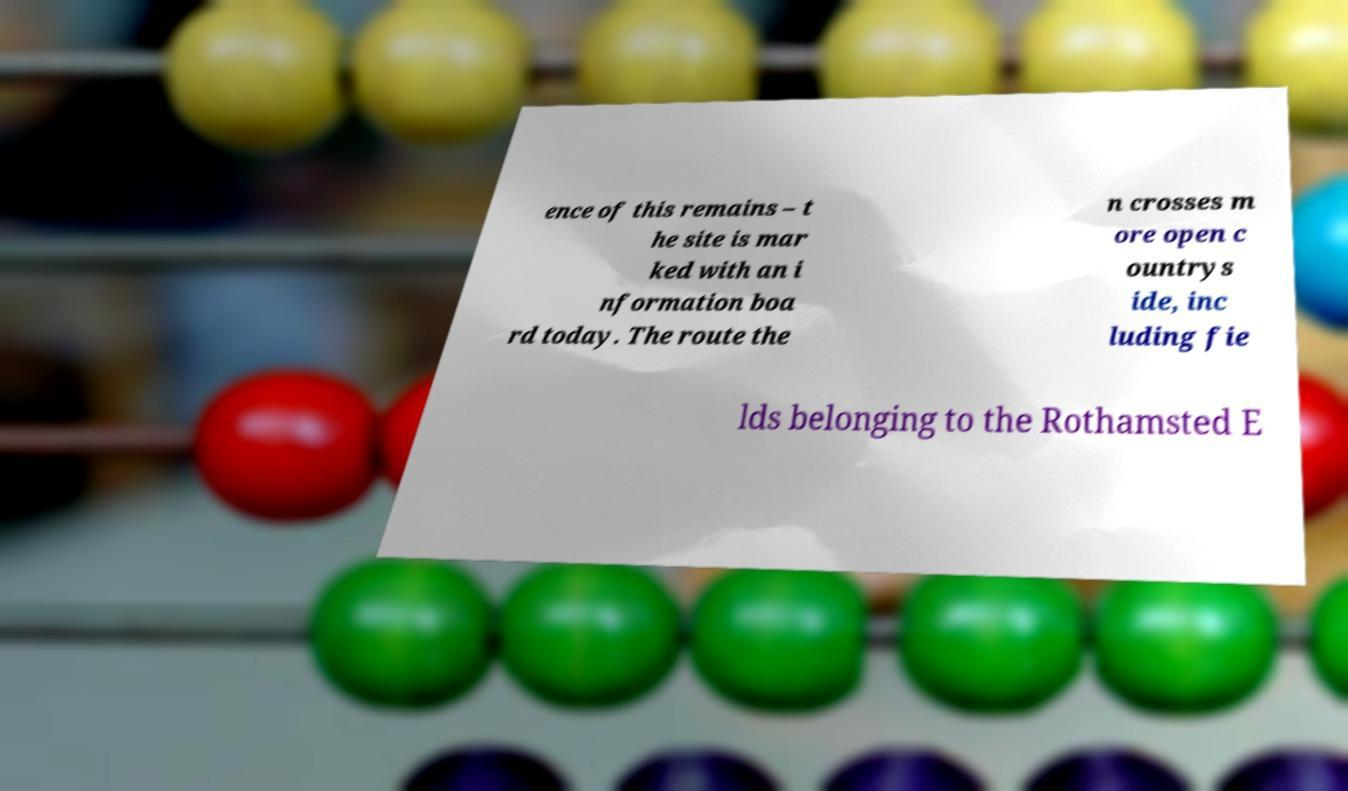Please read and relay the text visible in this image. What does it say? ence of this remains – t he site is mar ked with an i nformation boa rd today. The route the n crosses m ore open c ountrys ide, inc luding fie lds belonging to the Rothamsted E 